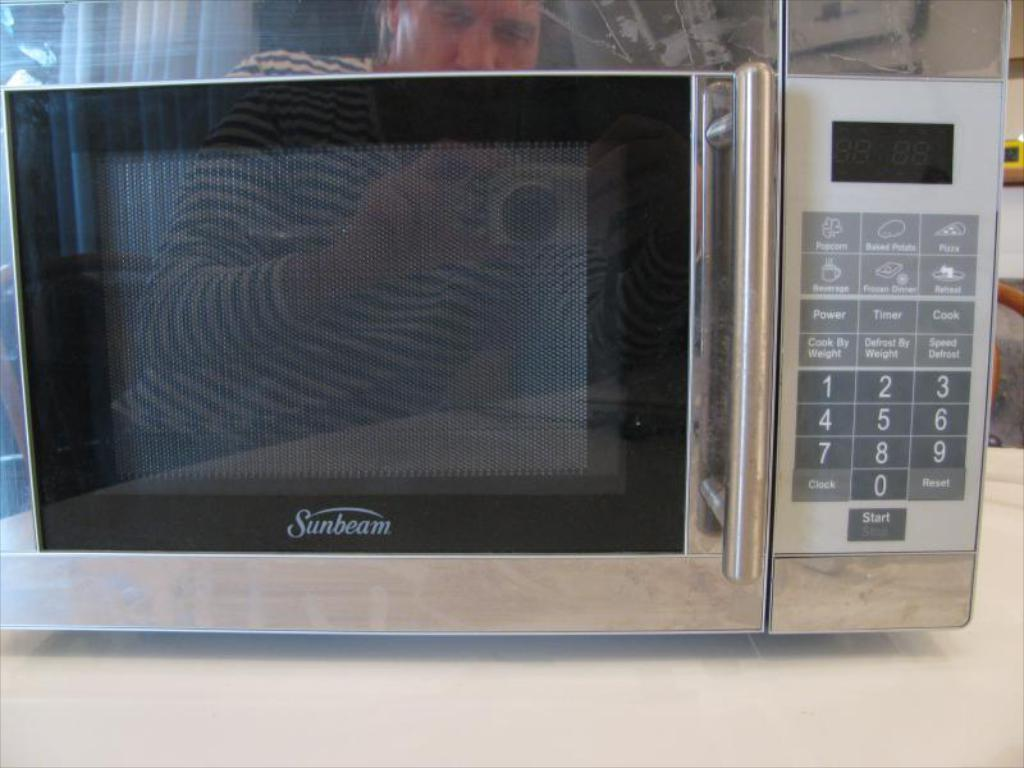<image>
Create a compact narrative representing the image presented. A Sunbeam microwave with a black door with digital number panel and start button on the right side of the door. 